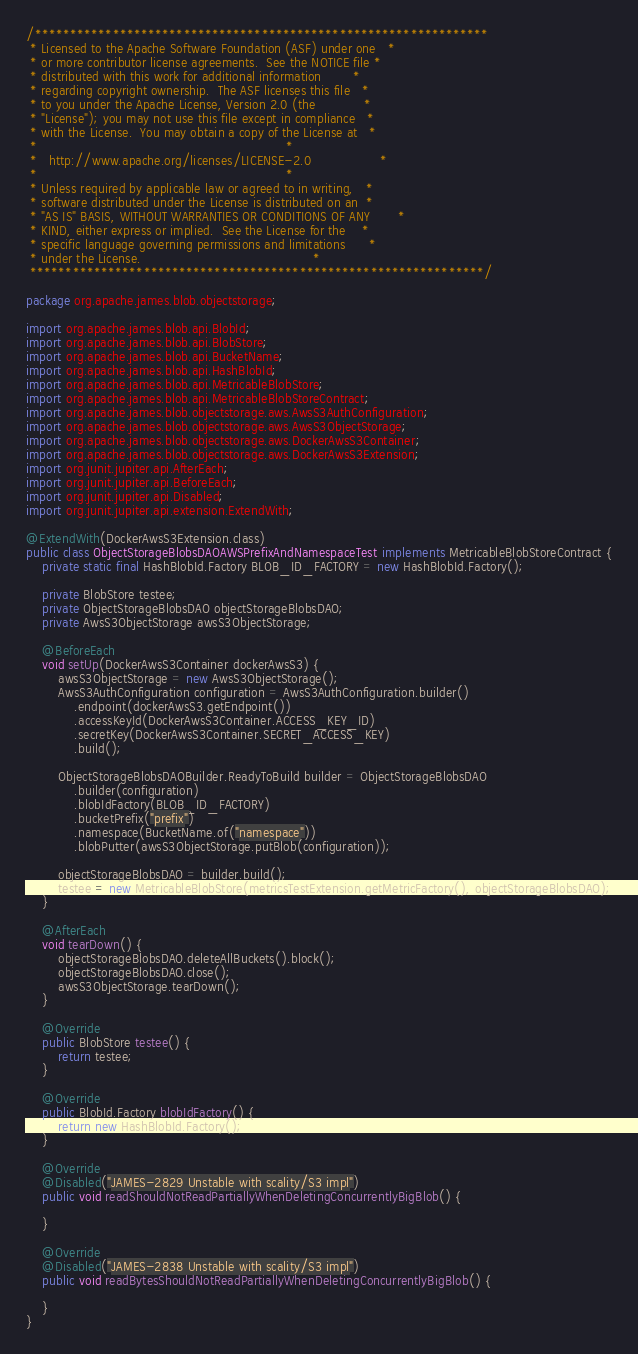<code> <loc_0><loc_0><loc_500><loc_500><_Java_>/****************************************************************
 * Licensed to the Apache Software Foundation (ASF) under one   *
 * or more contributor license agreements.  See the NOTICE file *
 * distributed with this work for additional information        *
 * regarding copyright ownership.  The ASF licenses this file   *
 * to you under the Apache License, Version 2.0 (the            *
 * "License"); you may not use this file except in compliance   *
 * with the License.  You may obtain a copy of the License at   *
 *                                                              *
 *   http://www.apache.org/licenses/LICENSE-2.0                 *
 *                                                              *
 * Unless required by applicable law or agreed to in writing,   *
 * software distributed under the License is distributed on an  *
 * "AS IS" BASIS, WITHOUT WARRANTIES OR CONDITIONS OF ANY       *
 * KIND, either express or implied.  See the License for the    *
 * specific language governing permissions and limitations      *
 * under the License.                                           *
 ****************************************************************/

package org.apache.james.blob.objectstorage;

import org.apache.james.blob.api.BlobId;
import org.apache.james.blob.api.BlobStore;
import org.apache.james.blob.api.BucketName;
import org.apache.james.blob.api.HashBlobId;
import org.apache.james.blob.api.MetricableBlobStore;
import org.apache.james.blob.api.MetricableBlobStoreContract;
import org.apache.james.blob.objectstorage.aws.AwsS3AuthConfiguration;
import org.apache.james.blob.objectstorage.aws.AwsS3ObjectStorage;
import org.apache.james.blob.objectstorage.aws.DockerAwsS3Container;
import org.apache.james.blob.objectstorage.aws.DockerAwsS3Extension;
import org.junit.jupiter.api.AfterEach;
import org.junit.jupiter.api.BeforeEach;
import org.junit.jupiter.api.Disabled;
import org.junit.jupiter.api.extension.ExtendWith;

@ExtendWith(DockerAwsS3Extension.class)
public class ObjectStorageBlobsDAOAWSPrefixAndNamespaceTest implements MetricableBlobStoreContract {
    private static final HashBlobId.Factory BLOB_ID_FACTORY = new HashBlobId.Factory();

    private BlobStore testee;
    private ObjectStorageBlobsDAO objectStorageBlobsDAO;
    private AwsS3ObjectStorage awsS3ObjectStorage;

    @BeforeEach
    void setUp(DockerAwsS3Container dockerAwsS3) {
        awsS3ObjectStorage = new AwsS3ObjectStorage();
        AwsS3AuthConfiguration configuration = AwsS3AuthConfiguration.builder()
            .endpoint(dockerAwsS3.getEndpoint())
            .accessKeyId(DockerAwsS3Container.ACCESS_KEY_ID)
            .secretKey(DockerAwsS3Container.SECRET_ACCESS_KEY)
            .build();

        ObjectStorageBlobsDAOBuilder.ReadyToBuild builder = ObjectStorageBlobsDAO
            .builder(configuration)
            .blobIdFactory(BLOB_ID_FACTORY)
            .bucketPrefix("prefix")
            .namespace(BucketName.of("namespace"))
            .blobPutter(awsS3ObjectStorage.putBlob(configuration));

        objectStorageBlobsDAO = builder.build();
        testee = new MetricableBlobStore(metricsTestExtension.getMetricFactory(), objectStorageBlobsDAO);
    }

    @AfterEach
    void tearDown() {
        objectStorageBlobsDAO.deleteAllBuckets().block();
        objectStorageBlobsDAO.close();
        awsS3ObjectStorage.tearDown();
    }

    @Override
    public BlobStore testee() {
        return testee;
    }

    @Override
    public BlobId.Factory blobIdFactory() {
        return new HashBlobId.Factory();
    }

    @Override
    @Disabled("JAMES-2829 Unstable with scality/S3 impl")
    public void readShouldNotReadPartiallyWhenDeletingConcurrentlyBigBlob() {

    }

    @Override
    @Disabled("JAMES-2838 Unstable with scality/S3 impl")
    public void readBytesShouldNotReadPartiallyWhenDeletingConcurrentlyBigBlob() {

    }
}

</code> 